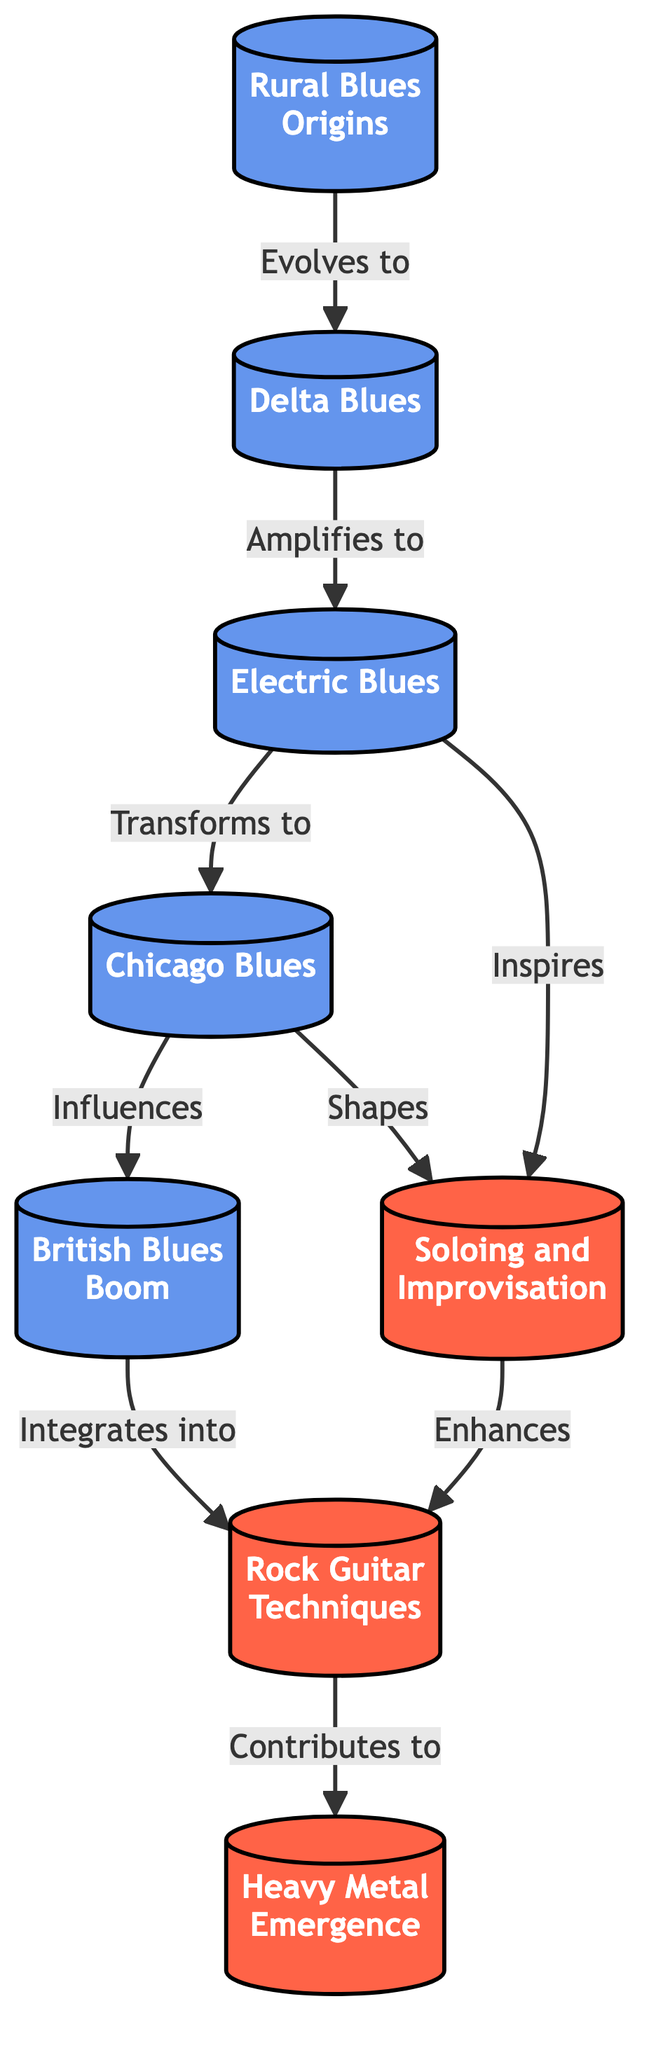What is the first node in the diagram? The first node is labeled "Rural Blues Origins" and is positioned at the top of the flow chart, indicating it as the starting point for the evolution of blues music.
Answer: Rural Blues Origins How many nodes are there in total? By counting all the unique labeled nodes in the diagram, we find there are a total of 8 nodes representing various styles and influences of blues music.
Answer: 8 What is the relationship between Delta Blues and Electric Blues? The diagram shows that Delta Blues is labeled as "Amplifies to" Electric Blues, indicating a direct evolution from Delta Blues into the amplified form of blues music characterized by the Electric Blues genre.
Answer: Amplifies to Which node directly influences the British Blues Boom? According to the flow chart, the node that directly influences the British Blues Boom is Chicago Blues, as illustrated by the arrow showing the flow from Chicago Blues to British Blues Boom.
Answer: Chicago Blues What techniques are derived from blues? The diagram identifies "Rock Guitar Techniques" as the category encompassing techniques derived from blues music, indicating a foundational influence in rock guitar playing.
Answer: Rock Guitar Techniques What evolves into Heavy Metal Emergence? The diagram indicates that Rock Guitar Techniques contribute to the emergence of Heavy Metal. This relationship shows how rock influences were pivotal in shaping the heavy metal genre.
Answer: Rock Guitar Techniques Which styles enhance soloing and improvisation? Both Electric Blues and Chicago Blues are shown to shape and inspire "Soloing and Improvisation," demonstrating their significant contributions to this aspect of music.
Answer: Electric Blues and Chicago Blues How does Soloing and Improvisation relate to Rock Guitar Techniques? The diagram shows that Soloing and Improvisation enhances Rock Guitar Techniques, indicating that the expressive improvisation leading from blues plays a crucial role in the development of rock guitar skills.
Answer: Enhances What is the significance of Expressive Vocals in Delta Blues? Delta Blues is characterized by expressive vocals, as described in the information node. This reflects the emotional depth and storytelling aspect that influences later rock music.
Answer: Expressive Vocals 